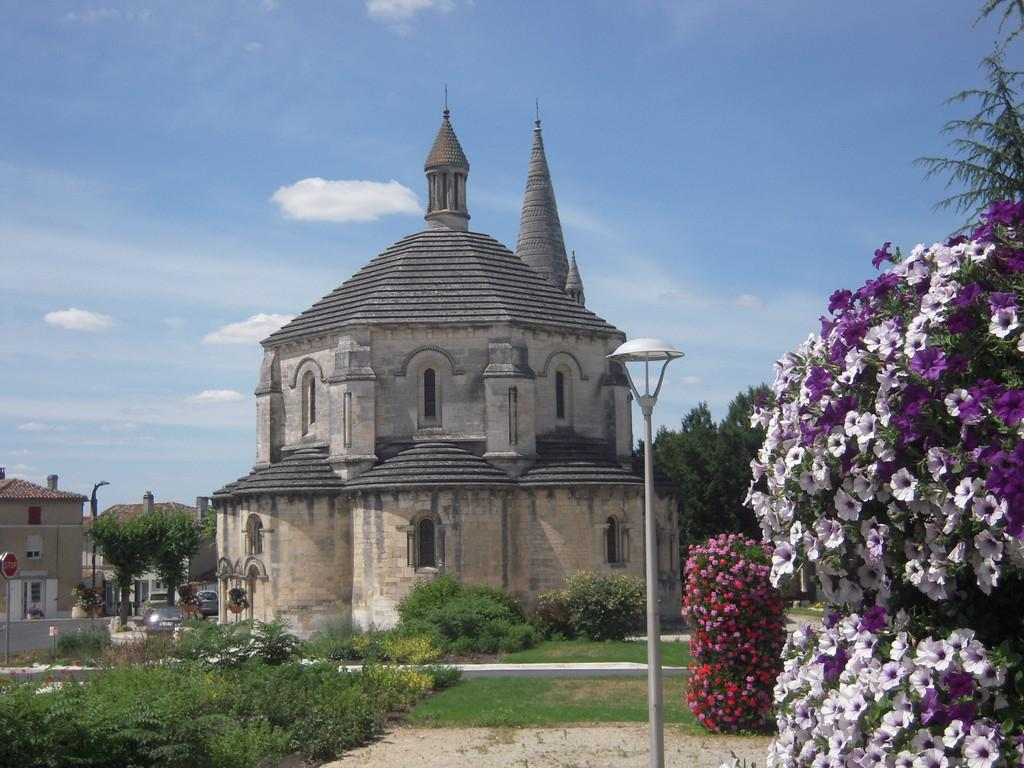What type of structures can be seen in the image? There are buildings in the image. What else can be seen in the image besides buildings? There are vehicles, poles, grass, plants, flowers, a board, and sky visible in the image. Can you describe the sky in the image? The sky is visible in the image, and there are clouds present. What type of vegetation is present in the image? There are plants and flowers in the image. How many screws can be seen holding the board in place in the image? There are no screws visible in the image; the board is not shown to be held in place by any screws. What type of shape is the board in the image? The shape of the board cannot be determined from the image, as it is not visible in enough detail. 